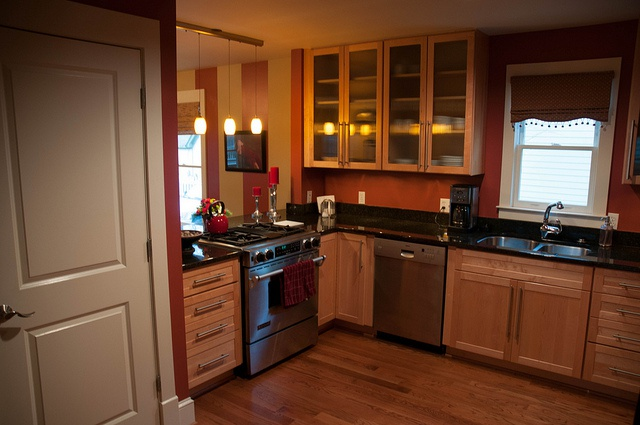Describe the objects in this image and their specific colors. I can see oven in black, maroon, gray, and blue tones, sink in black, gray, and blue tones, tv in black, maroon, and blue tones, vase in black, maroon, and brown tones, and bowl in black, maroon, and gray tones in this image. 